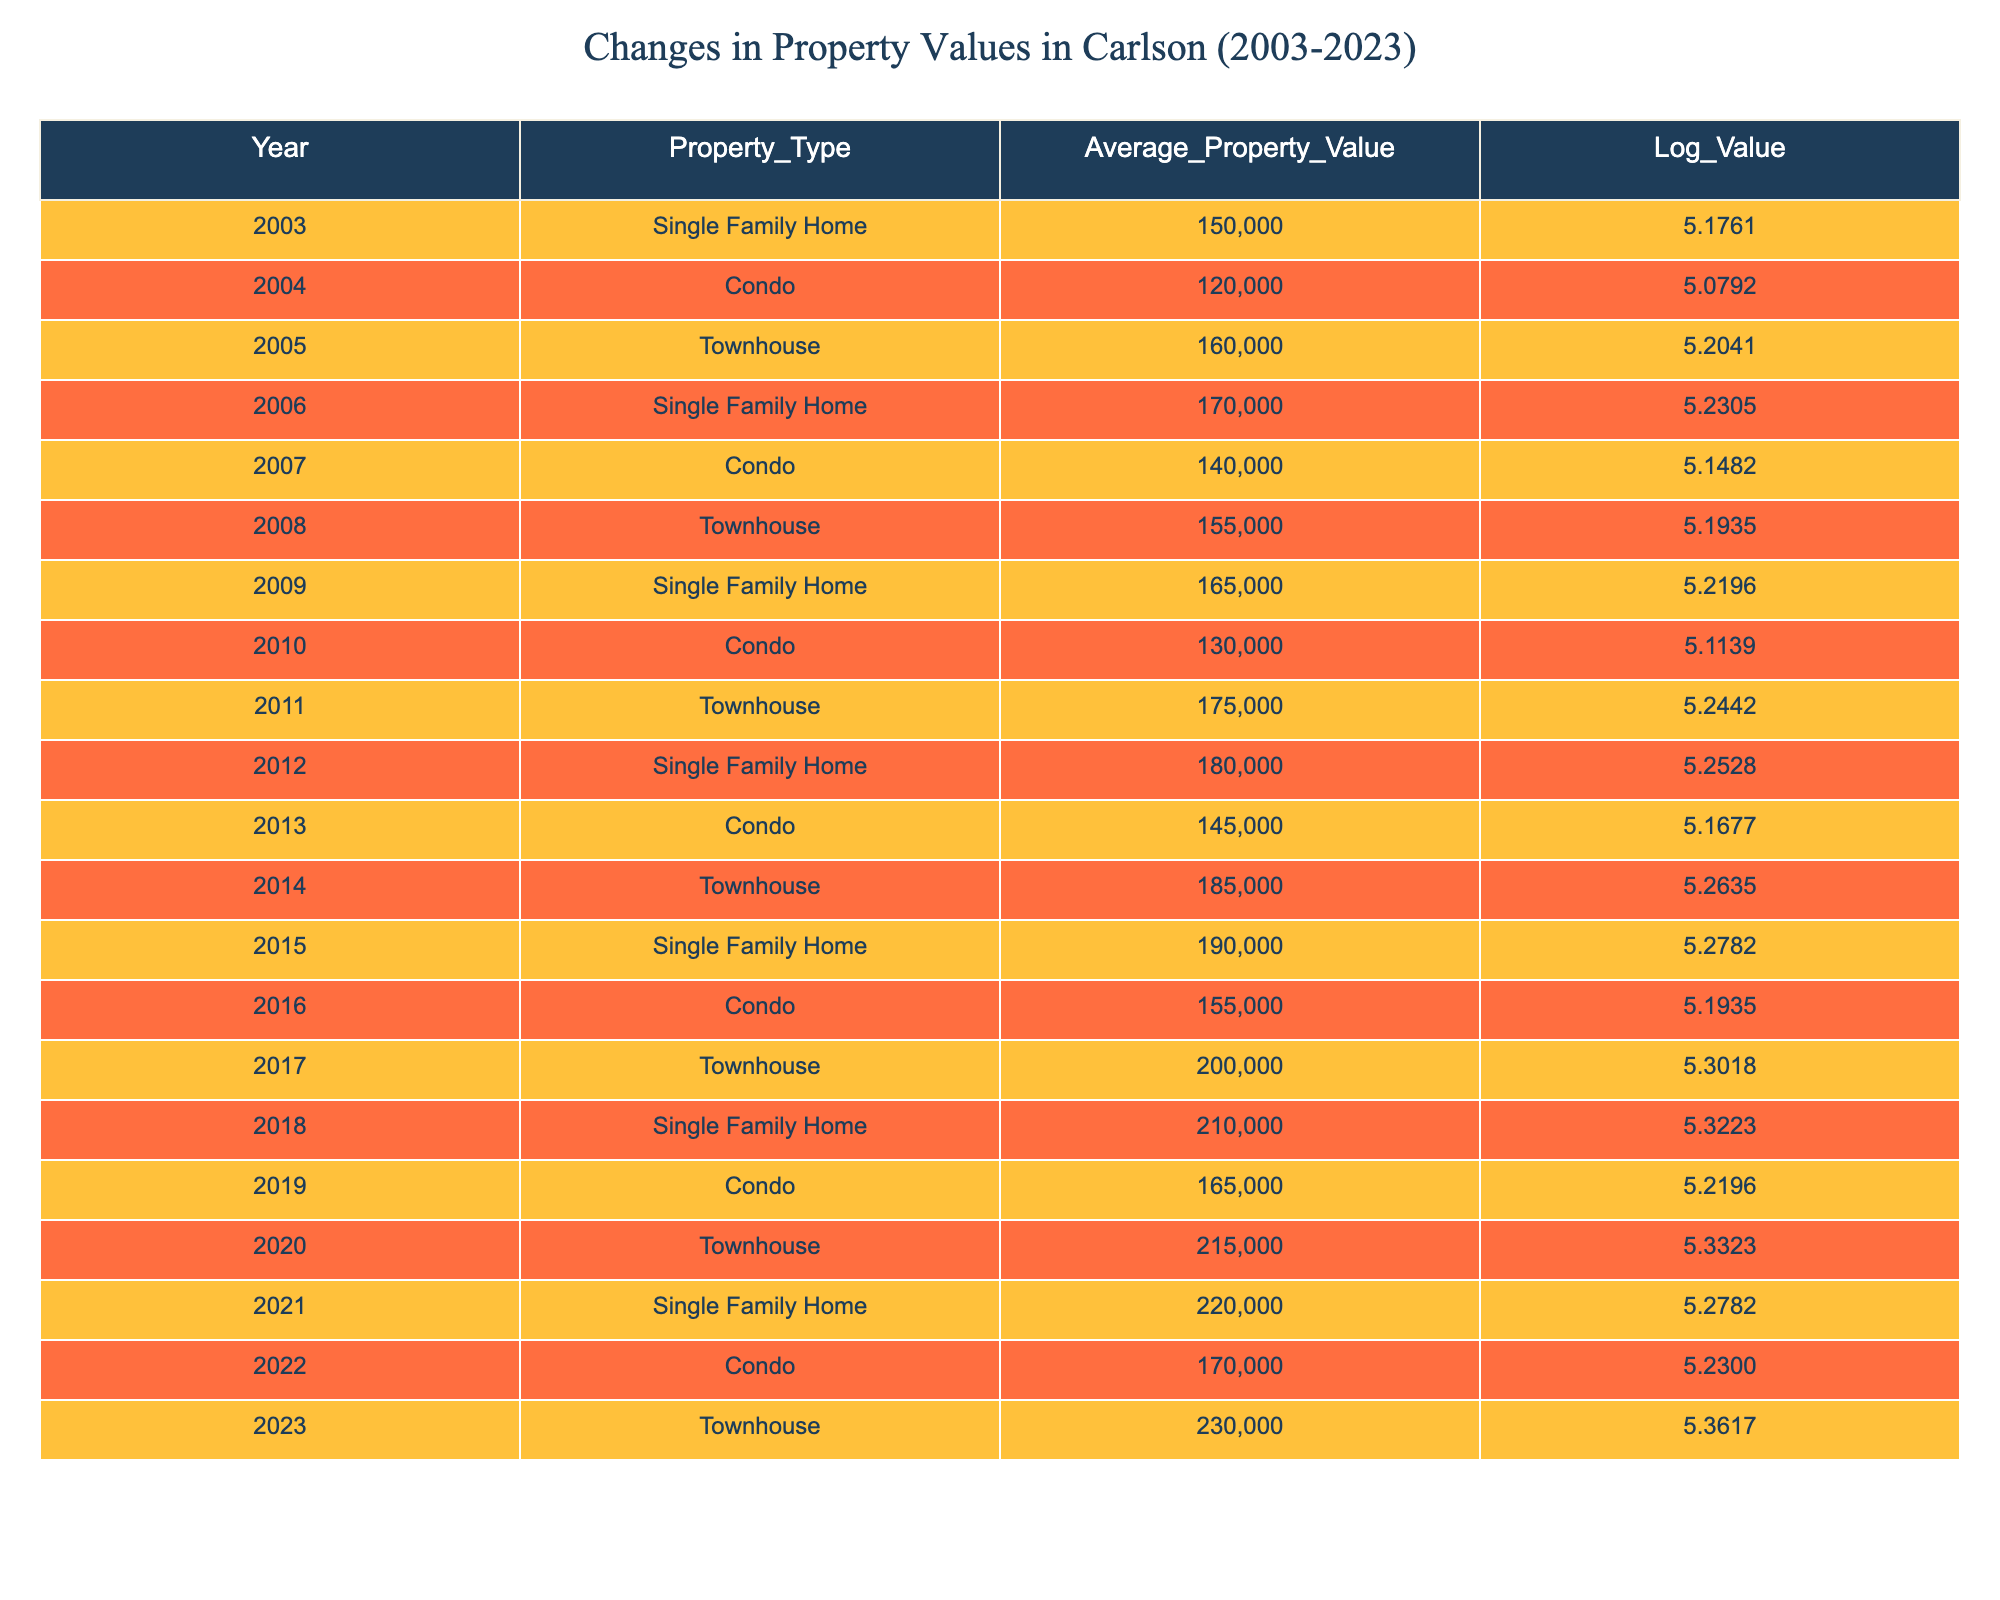What was the average property value for single family homes in 2003? The table shows that in 2003 the average property value for single family homes was 150000.
Answer: 150000 Which property type had the highest average value in 2023? In 2023, the table indicates that townhouses had the highest average property value at 230000.
Answer: Townhouse What is the difference in average property value between condos in 2010 and 2019? The average property value for condos in 2010 was 130000, and in 2019 it was 165000. The difference is 165000 - 130000 = 35000.
Answer: 35000 Did average townhouse values increase every year from 2003 to 2023? By examining the townhouse values from 2003 to 2023, the average values show a consistent increase without any decrease.
Answer: Yes What was the percentage increase in average property value for single family homes from 2003 to 2023? The average single family home value in 2003 was 150000 and in 2023 it was 220000. The increase is 220000 - 150000 = 70000. The percentage increase is (70000 / 150000) * 100 = 46.67%.
Answer: 46.67% What was the average value of condos over the given years in the table? To find the average value, we add the values for each year listed for condos: (120000 + 140000 + 130000 + 145000 + 155000 + 165000 + 170000) = 1020000. Dividing by the number of years (7), we obtain an average of 1020000 / 7 ≈ 145714.29.
Answer: 145714.29 